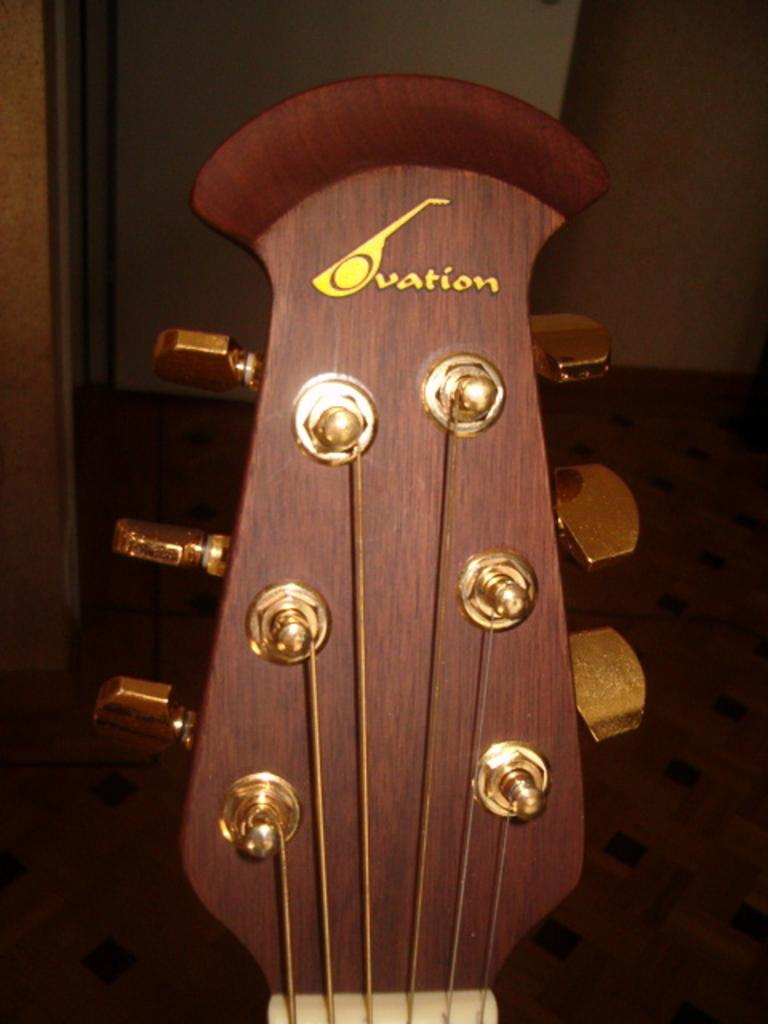What type of object is in the room that could be used for making music? There is an instrument in the room, which is likely a guitar. How many buttons are on the guitar? The guitar has 6 buttons, possibly referring to the guitar's tuning pegs. What is used to produce sound on the guitar? The guitar has strings that produce sound when plucked or strummed. What type of soup is being served on the linen in the image? There is no soup or linen present in the image; it features a guitar with strings and tuning pegs. 